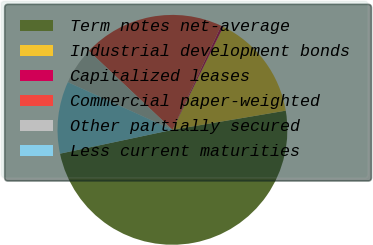Convert chart to OTSL. <chart><loc_0><loc_0><loc_500><loc_500><pie_chart><fcel>Term notes net-average<fcel>Industrial development bonds<fcel>Capitalized leases<fcel>Commercial paper-weighted<fcel>Other partially secured<fcel>Less current maturities<nl><fcel>49.34%<fcel>15.03%<fcel>0.33%<fcel>19.93%<fcel>5.23%<fcel>10.13%<nl></chart> 